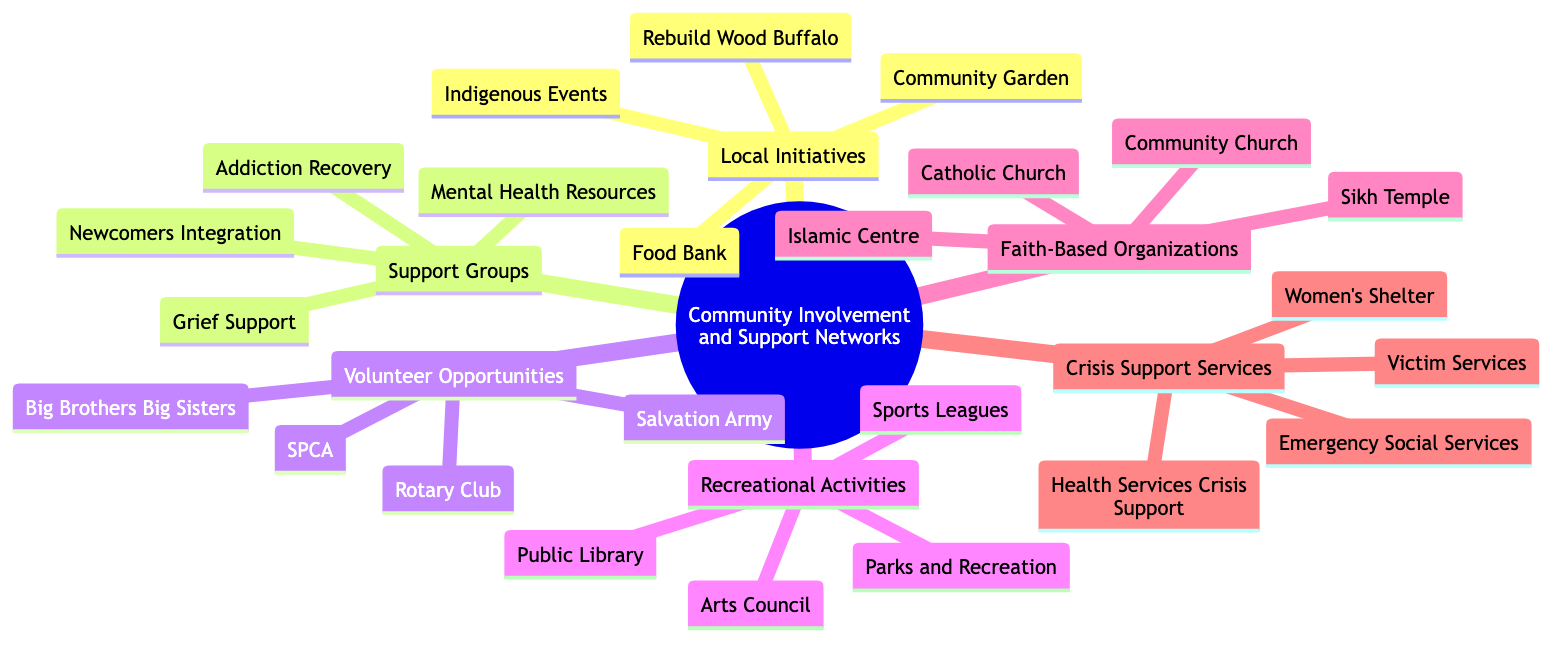What are two local initiatives listed in the diagram? The diagram shows multiple local initiatives. By examining the "Local Initiatives" node, we can identify "Fort McMurray Food Bank" and "Wood Buffalo Community Garden" as two examples.
Answer: Fort McMurray Food Bank, Wood Buffalo Community Garden How many support groups are mentioned? The "Support Groups" node contains four sub-nodes. By counting these, we find there are four groups: "Mental Health and Wellness Resources," "Grief and Bereavement Groups," "Substance Abuse Recovery Programs," and "Newcomers Integration Network."
Answer: 4 What type of organizations does the "Crisis Support Services" category include? The "Crisis Support Services" node specifies types of organizations that provide assistance in crises. These organizations include service providers like "Wood Buffalo Women's Shelter" and "Fort McMurray Victim Services."
Answer: Support service providers Which volunteer opportunity focuses on animal care? Within the "Volunteer Opportunities" node, "Fort McMurray SPCA" is specifically dedicated to animal care and rescue efforts, clearly indicated in the diagram.
Answer: Fort McMurray SPCA What are two faith-based organizations listed? The diagram contains a "Faith-Based Organizations" node with multiple examples. Two organizations are "MacDonald Island Community Church" and "Islamic Centre of Fort McMurray."
Answer: MacDonald Island Community Church, Islamic Centre of Fort McMurray Which category has the most examples or sub-nodes listed? To determine the category with the most examples, we assess the count of sub-nodes under each main category. The "Local Initiatives" category has four examples, while others also have four, creating a tie.
Answer: Local Initiatives, Support Groups, Volunteer Opportunities, Faith-Based Organizations, Crisis Support Services What type of support does the "Fort McMurray Women's Shelter" provide? The "Fort McMurray Women's Shelter" node specifies that it offers support services for victims of domestic violence, which is clearly indicated under the "Crisis Support Services" area of the diagram.
Answer: Support services for victims of domestic violence How many recreational activities are mentioned? The "Recreational Activities" node contains four sub-nodes. By counting these, we identify "Parks and Recreation," "Local Sports Leagues," "Fort McMurray Public Library," and "Arts Council Wood Buffalo." Thus, there are four recreational activities listed.
Answer: 4 